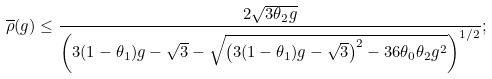Convert formula to latex. <formula><loc_0><loc_0><loc_500><loc_500>\overline { \rho } ( g ) & \leq \frac { 2 \sqrt { 3 \theta _ { 2 } g } } { \left ( { 3 ( 1 - \theta _ { 1 } ) g - \sqrt { 3 } - \sqrt { \left ( 3 ( 1 - \theta _ { 1 } ) g - \sqrt { 3 } \right ) ^ { 2 } - 3 6 \theta _ { 0 } \theta _ { 2 } g ^ { 2 } } } \right ) ^ { 1 / 2 } } ;</formula> 